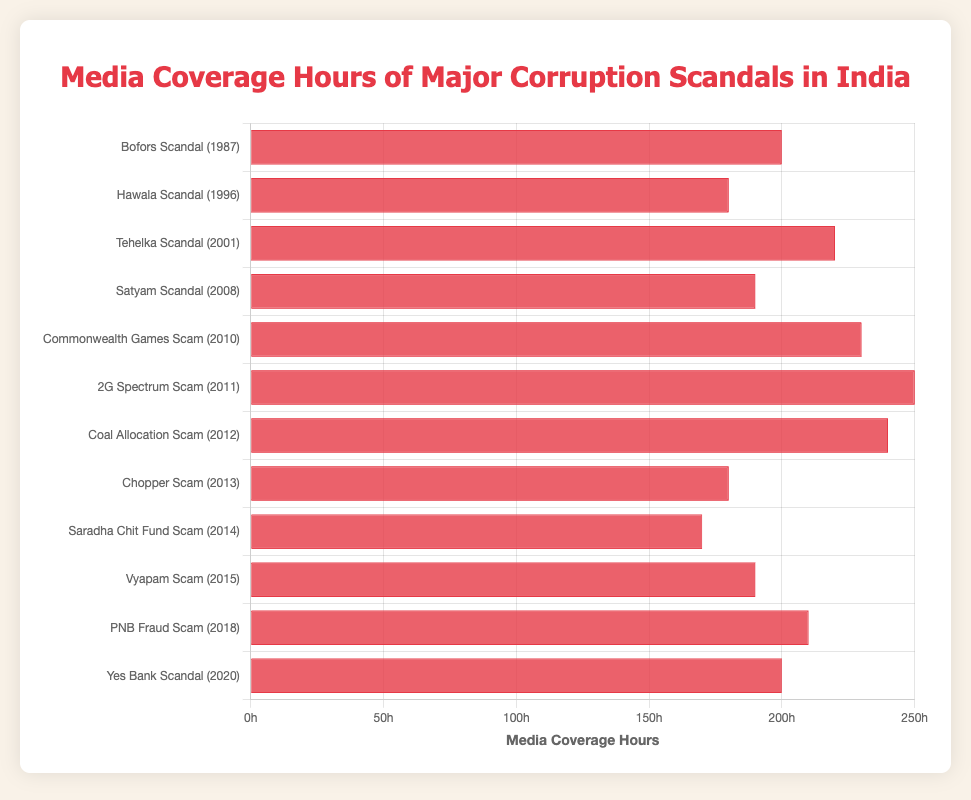Which scandal received the most media coverage hours? The bar representing the 2G Spectrum Scam (2011) is the longest in the chart, indicating it received the most media coverage hours.
Answer: 2G Spectrum Scam Which scandals received equal media coverage hours? The Bofors Scandal (1987) and the Yes Bank Scandal (2020) both have bars of the same length, indicating they received the same media coverage hours of 200 each.
Answer: Bofors Scandal, Yes Bank Scandal What is the difference in media coverage hours between the Commonwealth Games Scam (2010) and the Saradha Chit Fund Scam (2014)? The Commonwealth Games Scam has 230 hours of media coverage, and the Saradha Chit Fund Scam has 170 hours. The difference is 230 - 170 = 60 hours.
Answer: 60 hours What is the total media coverage hours for the Bofors Scandal (1987) and the Coal Allocation Scam (2012)? The Bofors Scandal has 200 hours, and the Coal Allocation Scam has 240 hours of media coverage. The total is 200 + 240 = 440 hours.
Answer: 440 hours What is the average media coverage hours among the top three scandals with the most coverage? The top three scandals by media coverage are the 2G Spectrum Scam (250 hours), Coal Allocation Scam (240 hours), and Commonwealth Games Scam (230 hours). The sum is 250 + 240 + 230 = 720 hours, and the average is 720 / 3 = 240 hours.
Answer: 240 hours Which scandal has a shorter bar than the Tehelka Scandal (220 hours) but longer than the Satyam Scandal (190 hours)? By comparing the bar lengths, the PNB Fraud Scam (2018) with 210 hours of coverage falls between the Tehelka Scandal and the Satyam Scandal.
Answer: PNB Fraud Scam What is the combined media coverage hours for scandals in the 2010s (2010-2019)? Summing up the scandals in the 2010s: Commonwealth Games Scam (230), 2G Spectrum Scam (250), Coal Allocation Scam (240), Chopper Scam (180), Saradha Chit Fund Scam (170), and Vyapam Scam (190) yields 230 + 250 + 240 + 180 + 170 + 190 = 1260 hours.
Answer: 1260 hours What is the median media coverage hours of the scandals listed? Arranging the coverage hours in ascending order: 170, 180, 180, 190, 190, 200, 200, 210, 220, 230, 240, 250. The median is the average of the 6th and 7th values: (200 + 200) / 2 = 200 hours.
Answer: 200 hours 